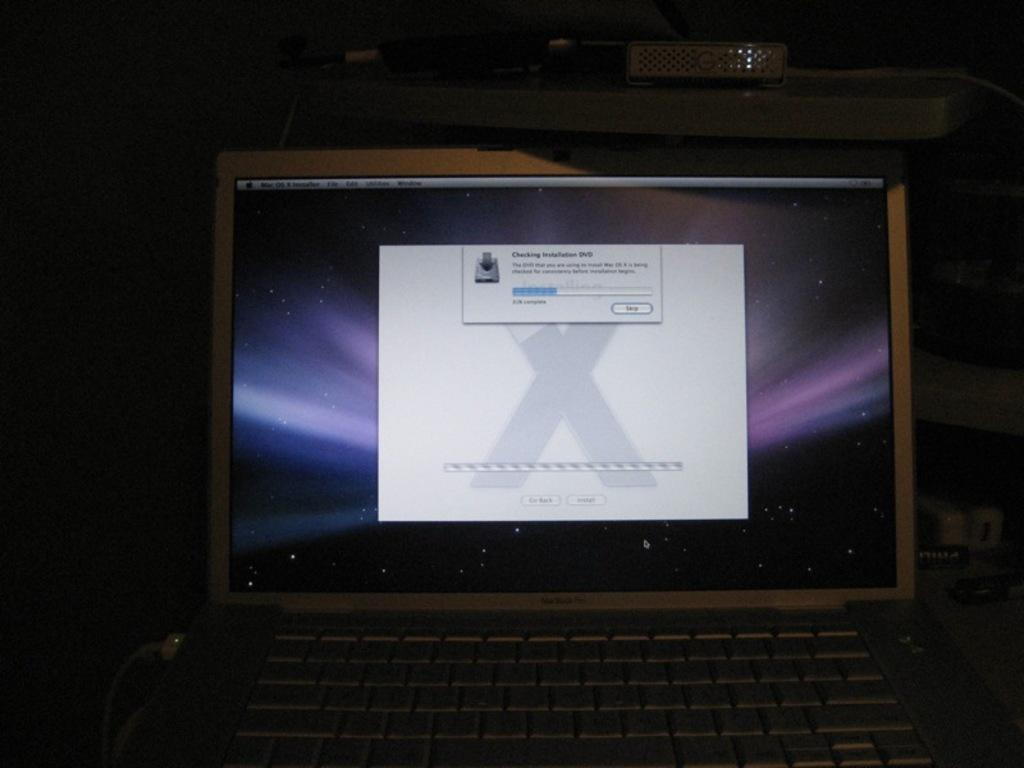<image>
Present a compact description of the photo's key features. A MacBook computer that is checking installation for a DVD. 